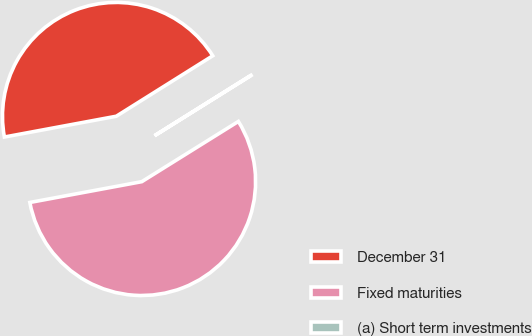Convert chart. <chart><loc_0><loc_0><loc_500><loc_500><pie_chart><fcel>December 31<fcel>Fixed maturities<fcel>(a) Short term investments<nl><fcel>44.01%<fcel>55.95%<fcel>0.04%<nl></chart> 